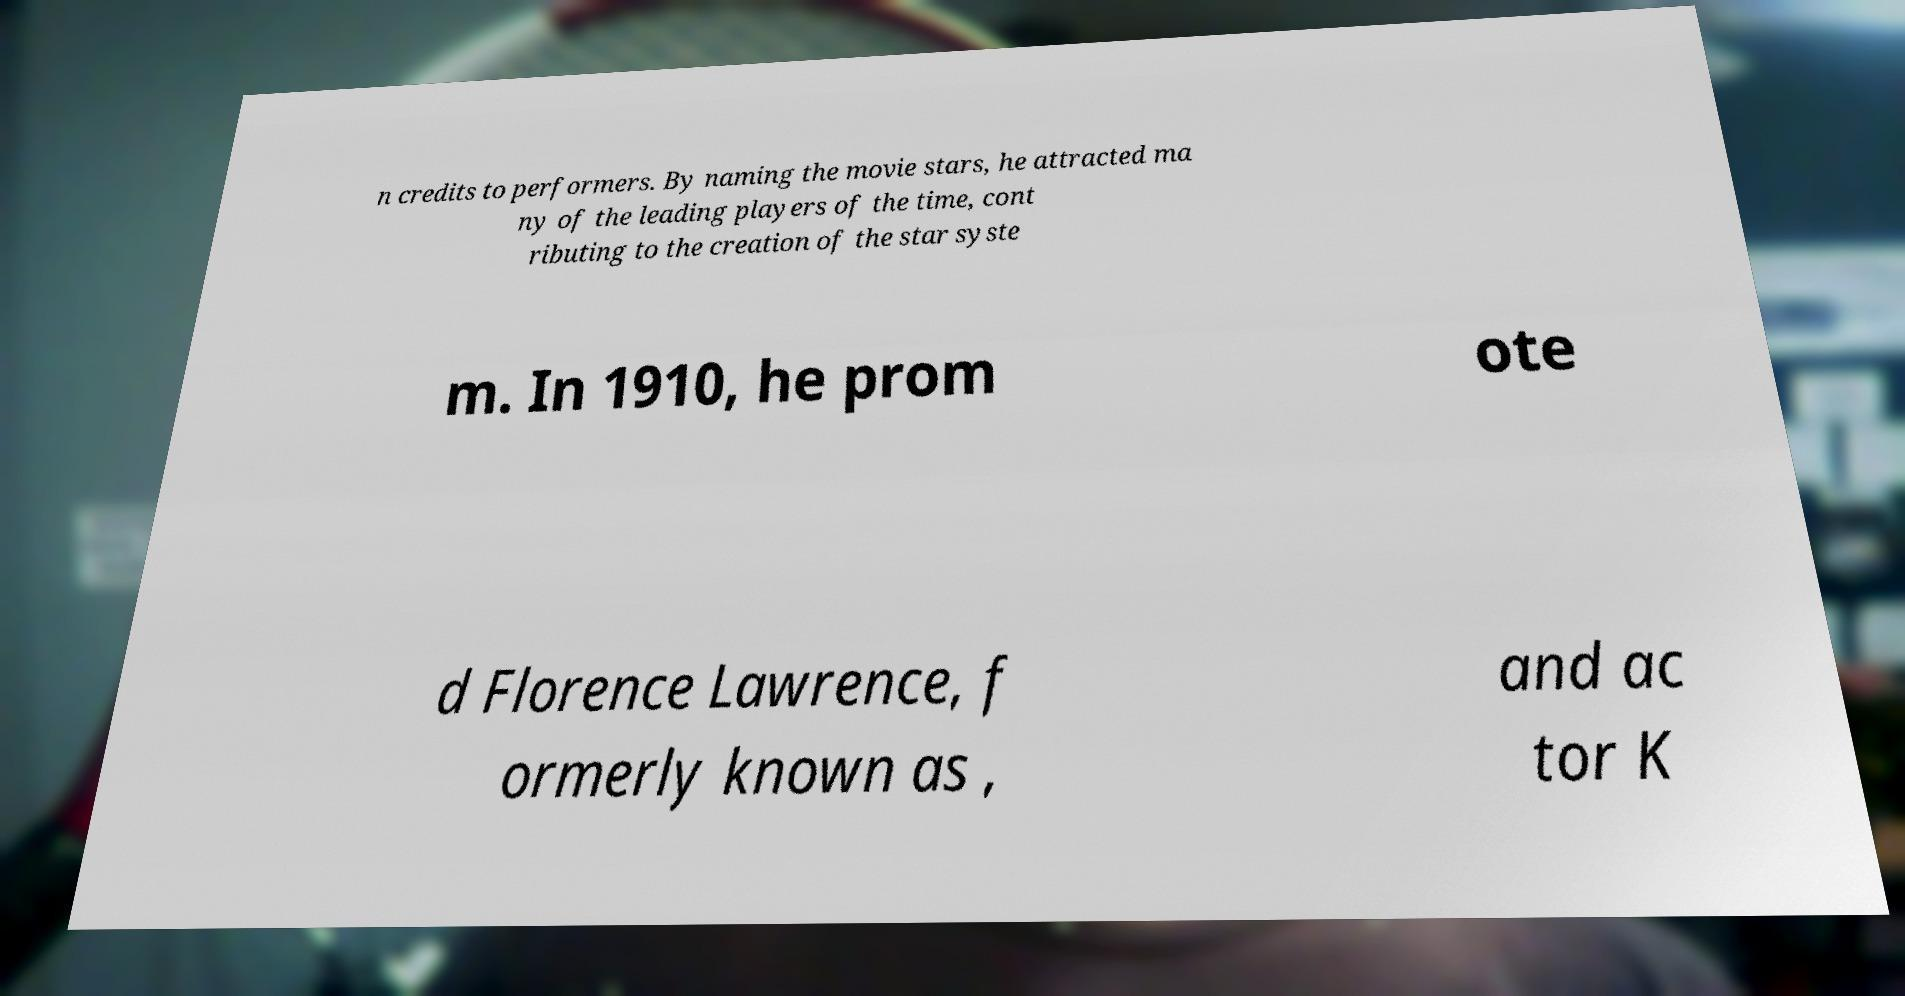What messages or text are displayed in this image? I need them in a readable, typed format. n credits to performers. By naming the movie stars, he attracted ma ny of the leading players of the time, cont ributing to the creation of the star syste m. In 1910, he prom ote d Florence Lawrence, f ormerly known as , and ac tor K 